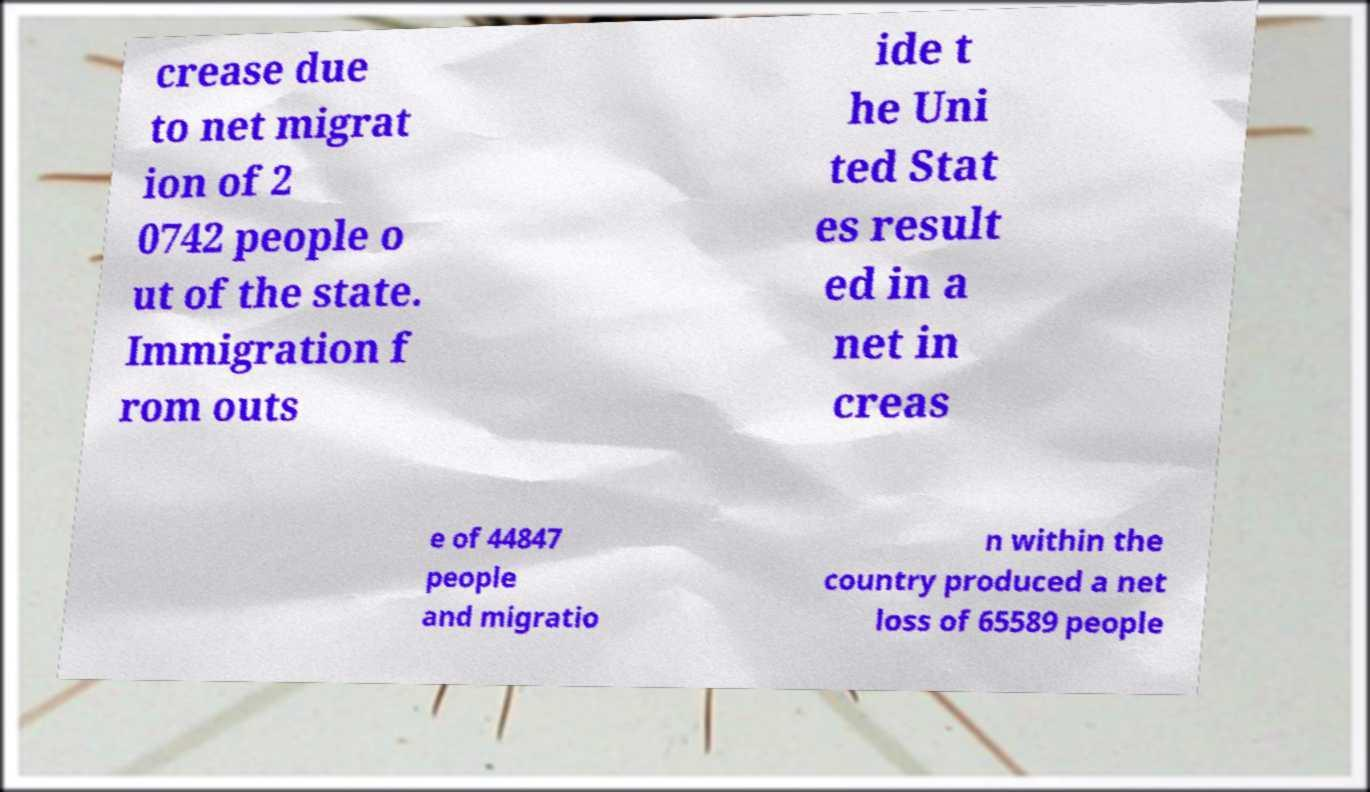There's text embedded in this image that I need extracted. Can you transcribe it verbatim? crease due to net migrat ion of 2 0742 people o ut of the state. Immigration f rom outs ide t he Uni ted Stat es result ed in a net in creas e of 44847 people and migratio n within the country produced a net loss of 65589 people 